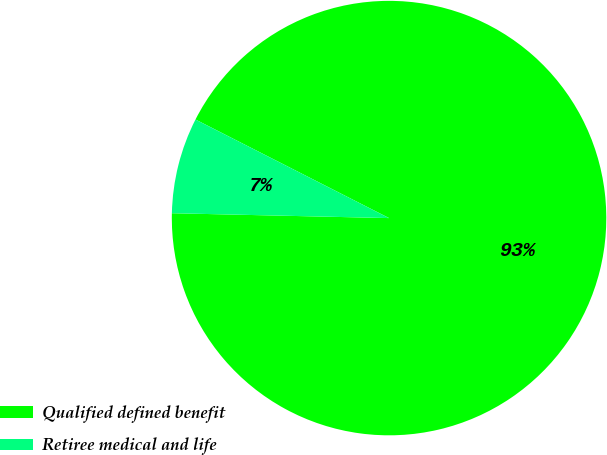<chart> <loc_0><loc_0><loc_500><loc_500><pie_chart><fcel>Qualified defined benefit<fcel>Retiree medical and life<nl><fcel>92.86%<fcel>7.14%<nl></chart> 